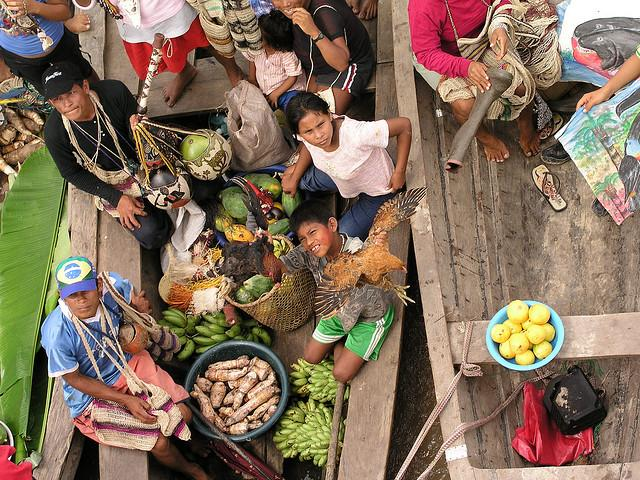Where are the persons here headed? market 